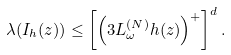<formula> <loc_0><loc_0><loc_500><loc_500>\lambda ( I _ { h } ( z ) ) \leq \left [ \left ( 3 L ^ { ( N ) } _ { \omega } h ( z ) \right ) ^ { + } \right ] ^ { d } .</formula> 